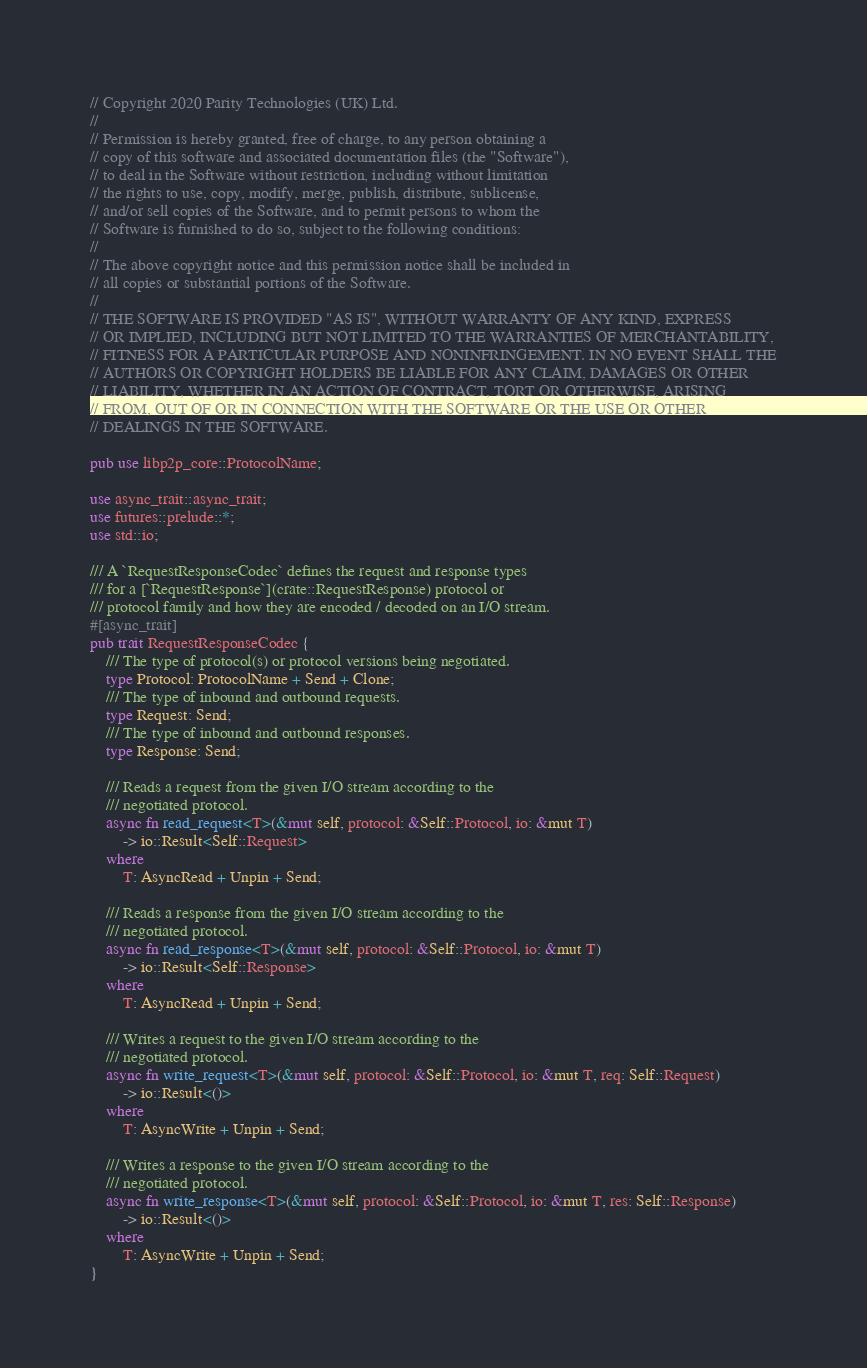<code> <loc_0><loc_0><loc_500><loc_500><_Rust_>// Copyright 2020 Parity Technologies (UK) Ltd.
//
// Permission is hereby granted, free of charge, to any person obtaining a
// copy of this software and associated documentation files (the "Software"),
// to deal in the Software without restriction, including without limitation
// the rights to use, copy, modify, merge, publish, distribute, sublicense,
// and/or sell copies of the Software, and to permit persons to whom the
// Software is furnished to do so, subject to the following conditions:
//
// The above copyright notice and this permission notice shall be included in
// all copies or substantial portions of the Software.
//
// THE SOFTWARE IS PROVIDED "AS IS", WITHOUT WARRANTY OF ANY KIND, EXPRESS
// OR IMPLIED, INCLUDING BUT NOT LIMITED TO THE WARRANTIES OF MERCHANTABILITY,
// FITNESS FOR A PARTICULAR PURPOSE AND NONINFRINGEMENT. IN NO EVENT SHALL THE
// AUTHORS OR COPYRIGHT HOLDERS BE LIABLE FOR ANY CLAIM, DAMAGES OR OTHER
// LIABILITY, WHETHER IN AN ACTION OF CONTRACT, TORT OR OTHERWISE, ARISING
// FROM, OUT OF OR IN CONNECTION WITH THE SOFTWARE OR THE USE OR OTHER
// DEALINGS IN THE SOFTWARE.

pub use libp2p_core::ProtocolName;

use async_trait::async_trait;
use futures::prelude::*;
use std::io;

/// A `RequestResponseCodec` defines the request and response types
/// for a [`RequestResponse`](crate::RequestResponse) protocol or
/// protocol family and how they are encoded / decoded on an I/O stream.
#[async_trait]
pub trait RequestResponseCodec {
    /// The type of protocol(s) or protocol versions being negotiated.
    type Protocol: ProtocolName + Send + Clone;
    /// The type of inbound and outbound requests.
    type Request: Send;
    /// The type of inbound and outbound responses.
    type Response: Send;

    /// Reads a request from the given I/O stream according to the
    /// negotiated protocol.
    async fn read_request<T>(&mut self, protocol: &Self::Protocol, io: &mut T)
        -> io::Result<Self::Request>
    where
        T: AsyncRead + Unpin + Send;

    /// Reads a response from the given I/O stream according to the
    /// negotiated protocol.
    async fn read_response<T>(&mut self, protocol: &Self::Protocol, io: &mut T)
        -> io::Result<Self::Response>
    where
        T: AsyncRead + Unpin + Send;

    /// Writes a request to the given I/O stream according to the
    /// negotiated protocol.
    async fn write_request<T>(&mut self, protocol: &Self::Protocol, io: &mut T, req: Self::Request)
        -> io::Result<()>
    where
        T: AsyncWrite + Unpin + Send;

    /// Writes a response to the given I/O stream according to the
    /// negotiated protocol.
    async fn write_response<T>(&mut self, protocol: &Self::Protocol, io: &mut T, res: Self::Response)
        -> io::Result<()>
    where
        T: AsyncWrite + Unpin + Send;
}

</code> 